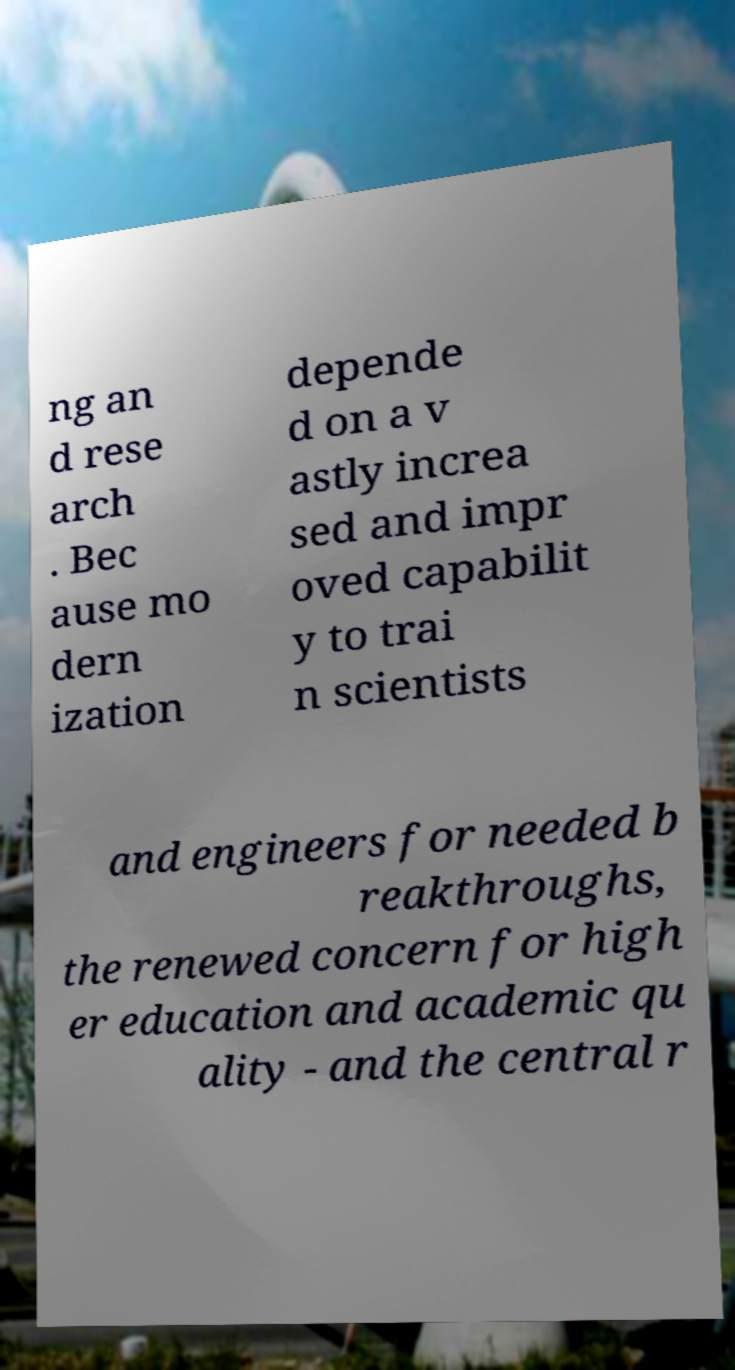Can you read and provide the text displayed in the image?This photo seems to have some interesting text. Can you extract and type it out for me? ng an d rese arch . Bec ause mo dern ization depende d on a v astly increa sed and impr oved capabilit y to trai n scientists and engineers for needed b reakthroughs, the renewed concern for high er education and academic qu ality - and the central r 